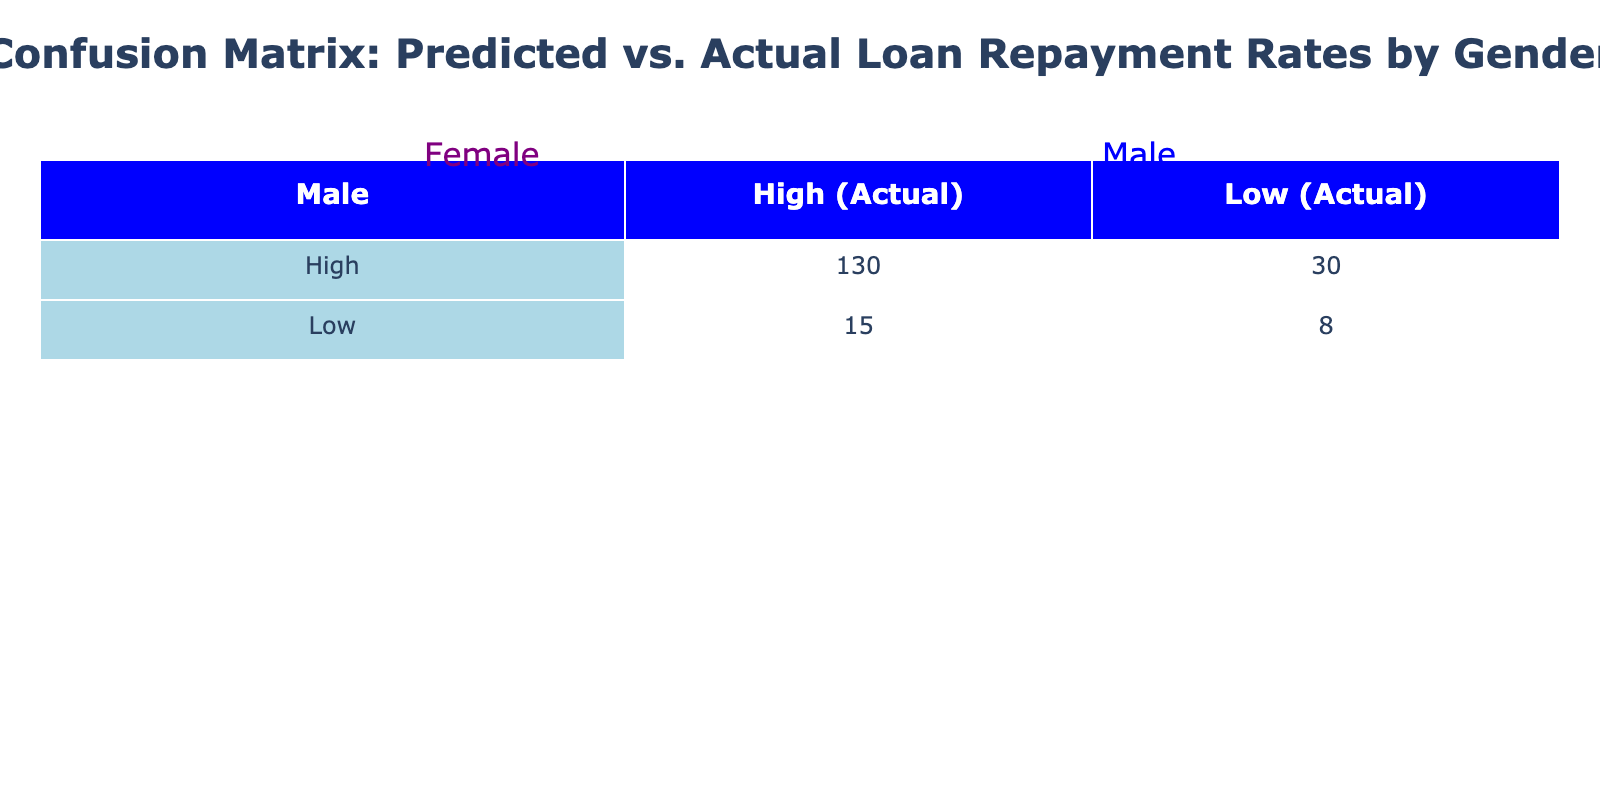What is the number of females who had a high predicted and actual loan repayment? From the table, we look at the row for females where both predicted and actual loan repayment are "High". The count shows 150 for this combination.
Answer: 150 What is the total number of males who had a low predicted loan repayment? For males, we sum the counts in the rows where the predicted loan repayment is "Low". This includes 15 (Low, High) and 8 (Low, Low), giving us a total of 15 + 8 = 23.
Answer: 23 Is it true that more females than males had a low actual loan repayment despite a high predicted loan repayment? Looking at the "High" predicted row for both genders, females have 20 (high predicted, low actual), whereas males have 30. Thus, it is not true as females (20) are fewer than males (30).
Answer: No What is the difference in the number of females and males who had a high predicted loan repayment but a low actual loan repayment? From the table, for females with high predicted but low actual, the count is 20, and for males, it is 30. The difference is 30 - 20 = 10 favoring males.
Answer: 10 How many total loan repayments were predicted as high for both genders? We calculate the total high predicted loan repayments by summing both female and male high predicted counts: Female (150 + 20) + Male (130 + 30) = 300.
Answer: 300 What proportion of females had actual low loan repayment? The number of females with actual low loan repayments is 20 (Predicted High, Actual Low) + 5 (Predicted Low, Actual Low) = 25. The total number of female repayments is 150 + 20 + 10 + 5 = 185. Thus, the proportion is 25/185 = approximately 0.135.
Answer: 0.135 What is the average number of loan repayments for each gender predicted as high? For females, the count is 150 (High, High) + 20 (High, Low) = 170. For males, we have 130 (High, High) + 30 (High, Low) = 160. Average for both genders (170 + 160) / 2 = 165.
Answer: 165 Are there any cases of males with actual low loan repayment where the prediction was low? From the table, we see that males have 8 cases of low predicted and low actual loan repayments. Hence, there are cases fitting this criterion.
Answer: Yes What is the total number of individuals who had a high actual loan repayment across both genders? The number of individuals with high actual repayment is 150 (Female, High, High) + 10 (Female, Low, High) + 130 (Male, High, High) + 15 (Male, High, Low) = 305.
Answer: 305 